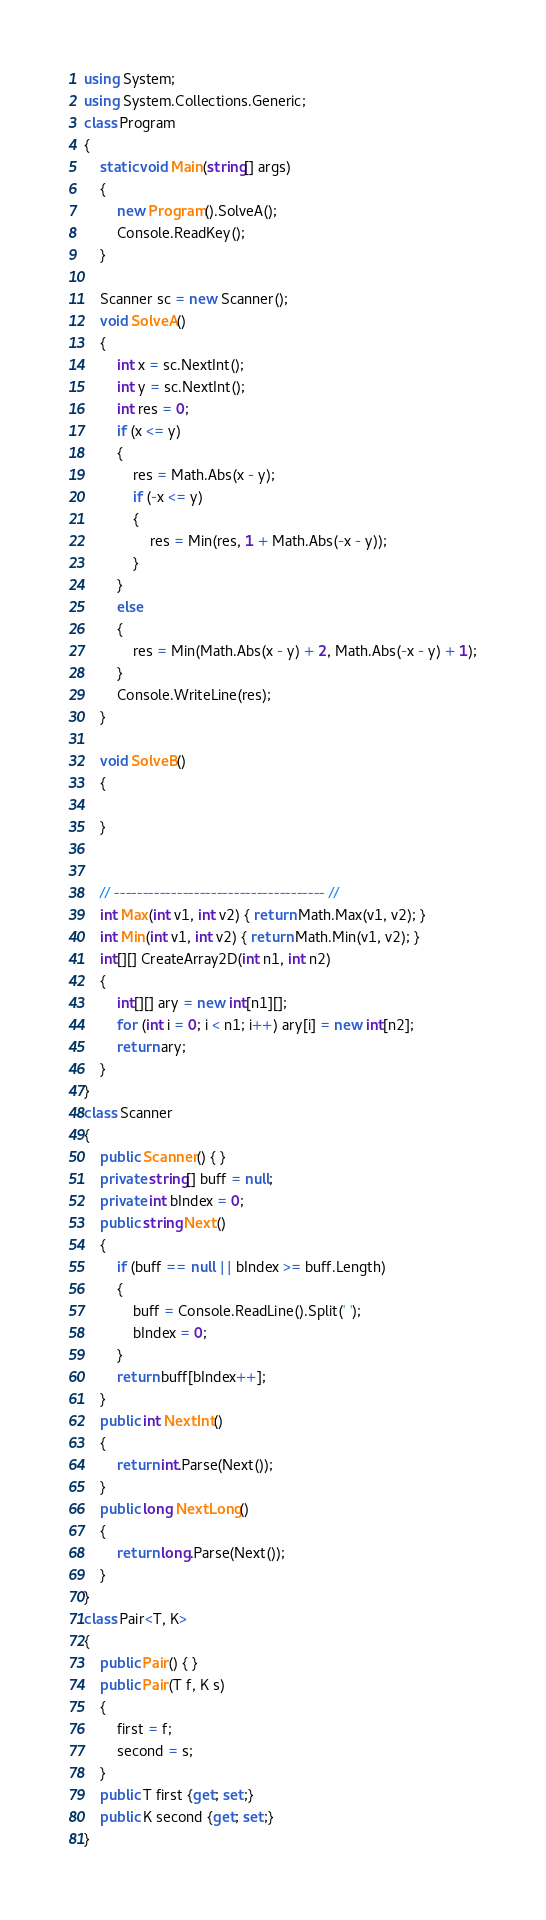<code> <loc_0><loc_0><loc_500><loc_500><_C#_>using System;
using System.Collections.Generic;
class Program
{
    static void Main(string[] args)
    {
        new Program().SolveA();
        Console.ReadKey();
    }

    Scanner sc = new Scanner();
    void SolveA()
    {
        int x = sc.NextInt();
        int y = sc.NextInt();
        int res = 0;
        if (x <= y)
        {
            res = Math.Abs(x - y);
            if (-x <= y)
            {
                res = Min(res, 1 + Math.Abs(-x - y));
            }
        }
        else
        {
            res = Min(Math.Abs(x - y) + 2, Math.Abs(-x - y) + 1);
        }
        Console.WriteLine(res);
    }

    void SolveB()
    {

    }


    // ------------------------------------- //
    int Max(int v1, int v2) { return Math.Max(v1, v2); }
    int Min(int v1, int v2) { return Math.Min(v1, v2); }
    int[][] CreateArray2D(int n1, int n2)
    {
        int[][] ary = new int[n1][];
        for (int i = 0; i < n1; i++) ary[i] = new int[n2];
        return ary;
    }
}
class Scanner
{
    public Scanner() { }
    private string[] buff = null;
    private int bIndex = 0;
    public string Next()
    {
        if (buff == null || bIndex >= buff.Length)
        {
            buff = Console.ReadLine().Split(' ');
            bIndex = 0;
        }
        return buff[bIndex++];
    }
    public int NextInt()
    {
        return int.Parse(Next());
    }
    public long NextLong()
    {
        return long.Parse(Next());
    }
}
class Pair<T, K>
{
    public Pair() { }
    public Pair(T f, K s)
    {
        first = f;
        second = s;
    }
    public T first {get; set;}
    public K second {get; set;}
}</code> 